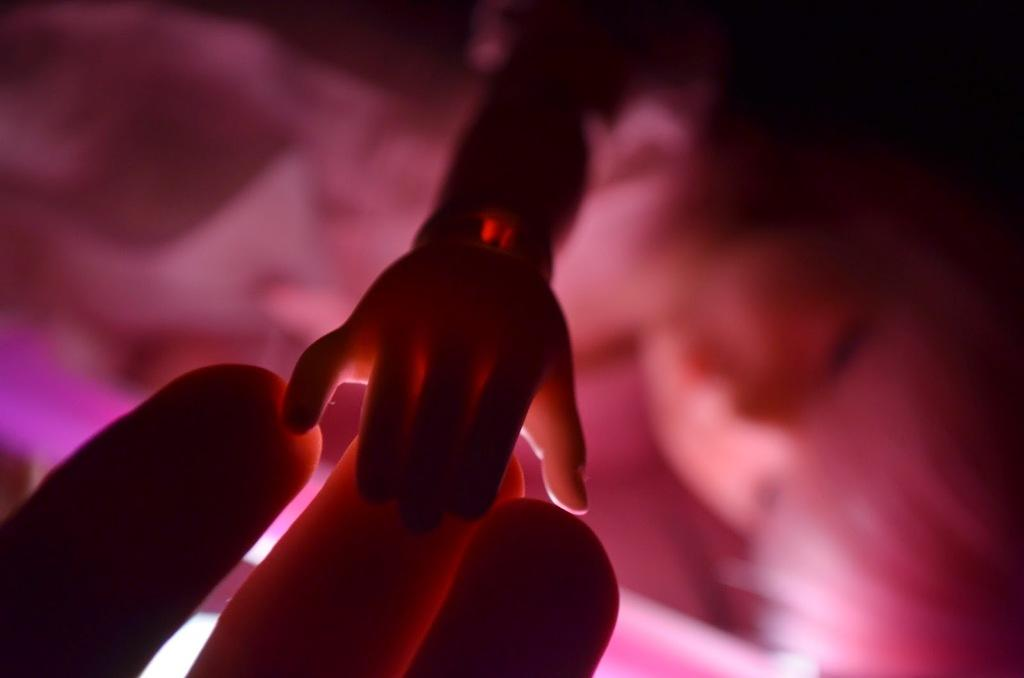What is the main subject of the image? There is a doll in the image. Can you describe any other details visible in the image? There are fingers visible in the image. What type of bird can be seen flying over the boat in the image? There is no bird or boat present in the image; it only features a doll and visible fingers. 